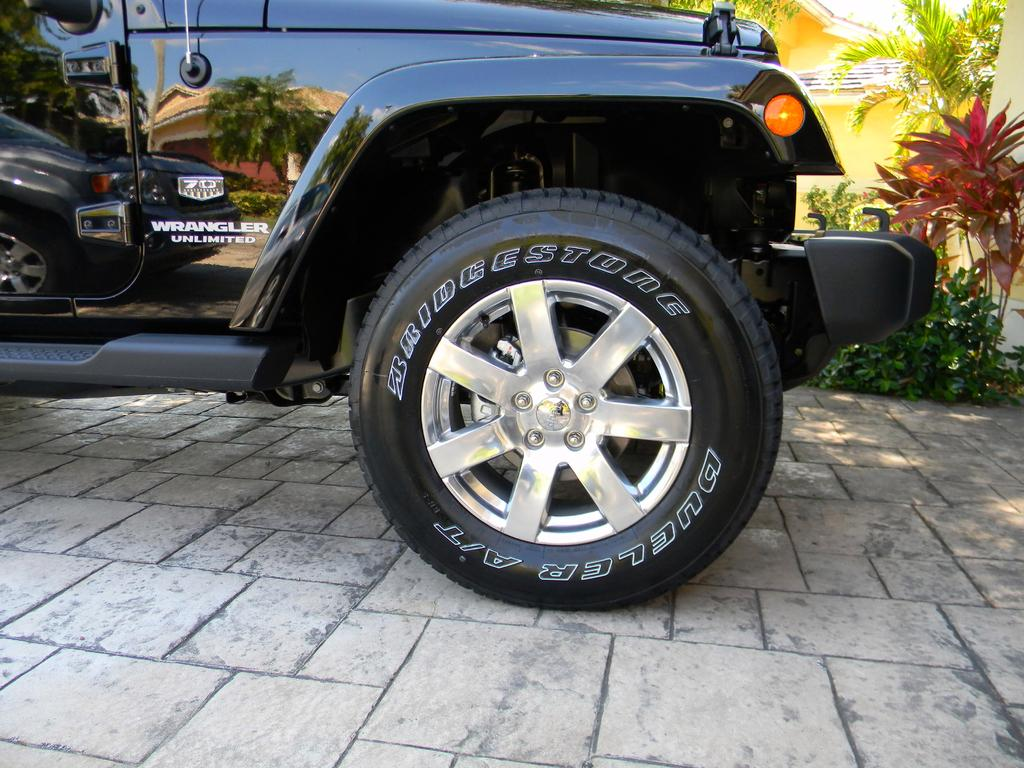What part of a vehicle can be seen in the image? There is a front tire of a vehicle in the image. What is the tire resting on? The tire is on a surface. What can be seen in the background of the image? There are trees and a building behind the vehicle in the image. Where are the dolls placed in the image? There are no dolls present in the image. 